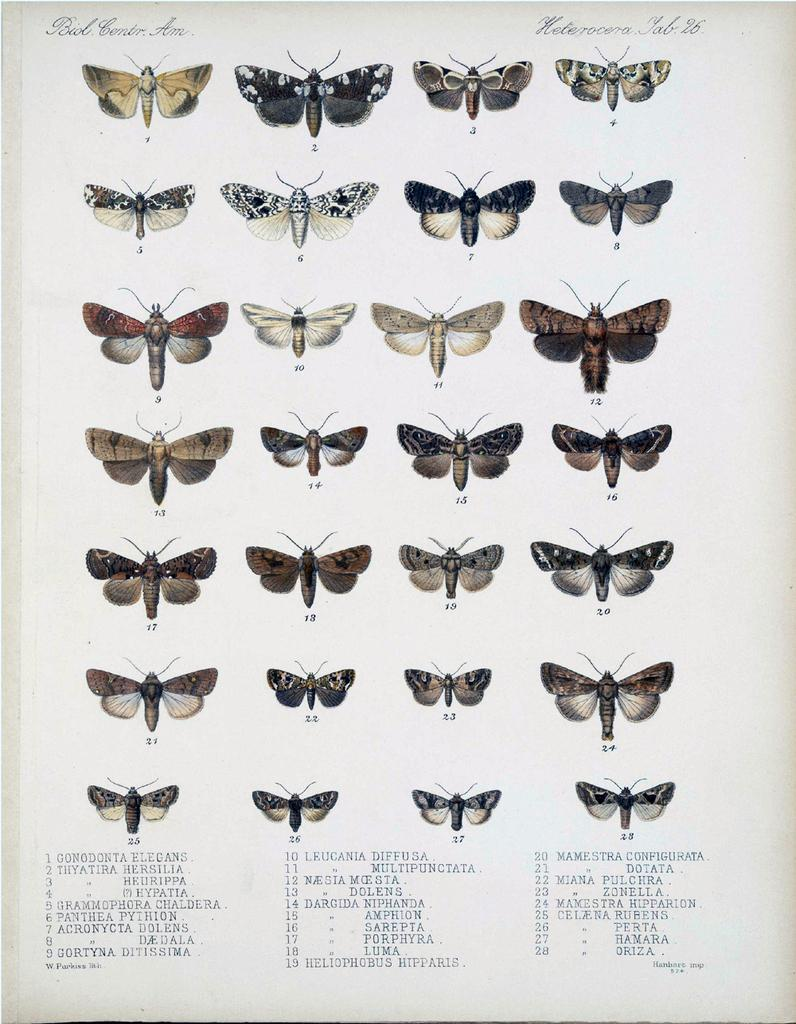What types of creatures are featured in the image? There are different types of butterflies in the image. What else can be seen in the image besides the butterflies? There is text at the top and bottom of the image. What type of silk is being used to make the sheet in the image? There is no sheet or silk present in the image; it features butterflies and text. How many children are visible in the image? There are no children present in the image. 